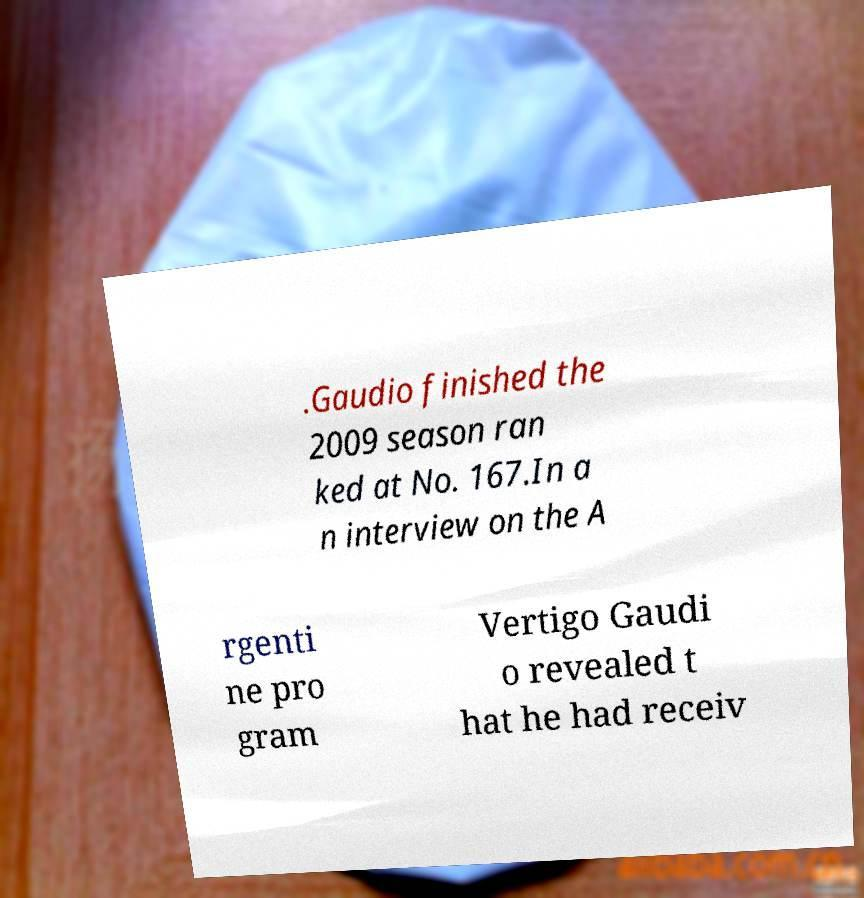I need the written content from this picture converted into text. Can you do that? .Gaudio finished the 2009 season ran ked at No. 167.In a n interview on the A rgenti ne pro gram Vertigo Gaudi o revealed t hat he had receiv 